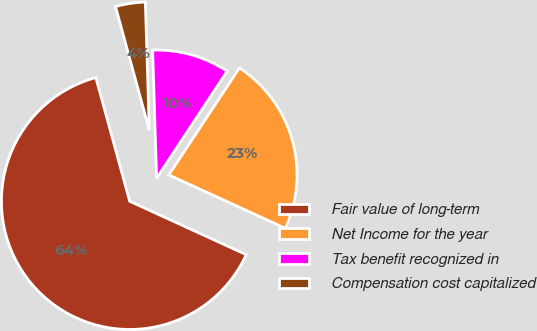<chart> <loc_0><loc_0><loc_500><loc_500><pie_chart><fcel>Fair value of long-term<fcel>Net Income for the year<fcel>Tax benefit recognized in<fcel>Compensation cost capitalized<nl><fcel>63.91%<fcel>22.56%<fcel>9.77%<fcel>3.76%<nl></chart> 